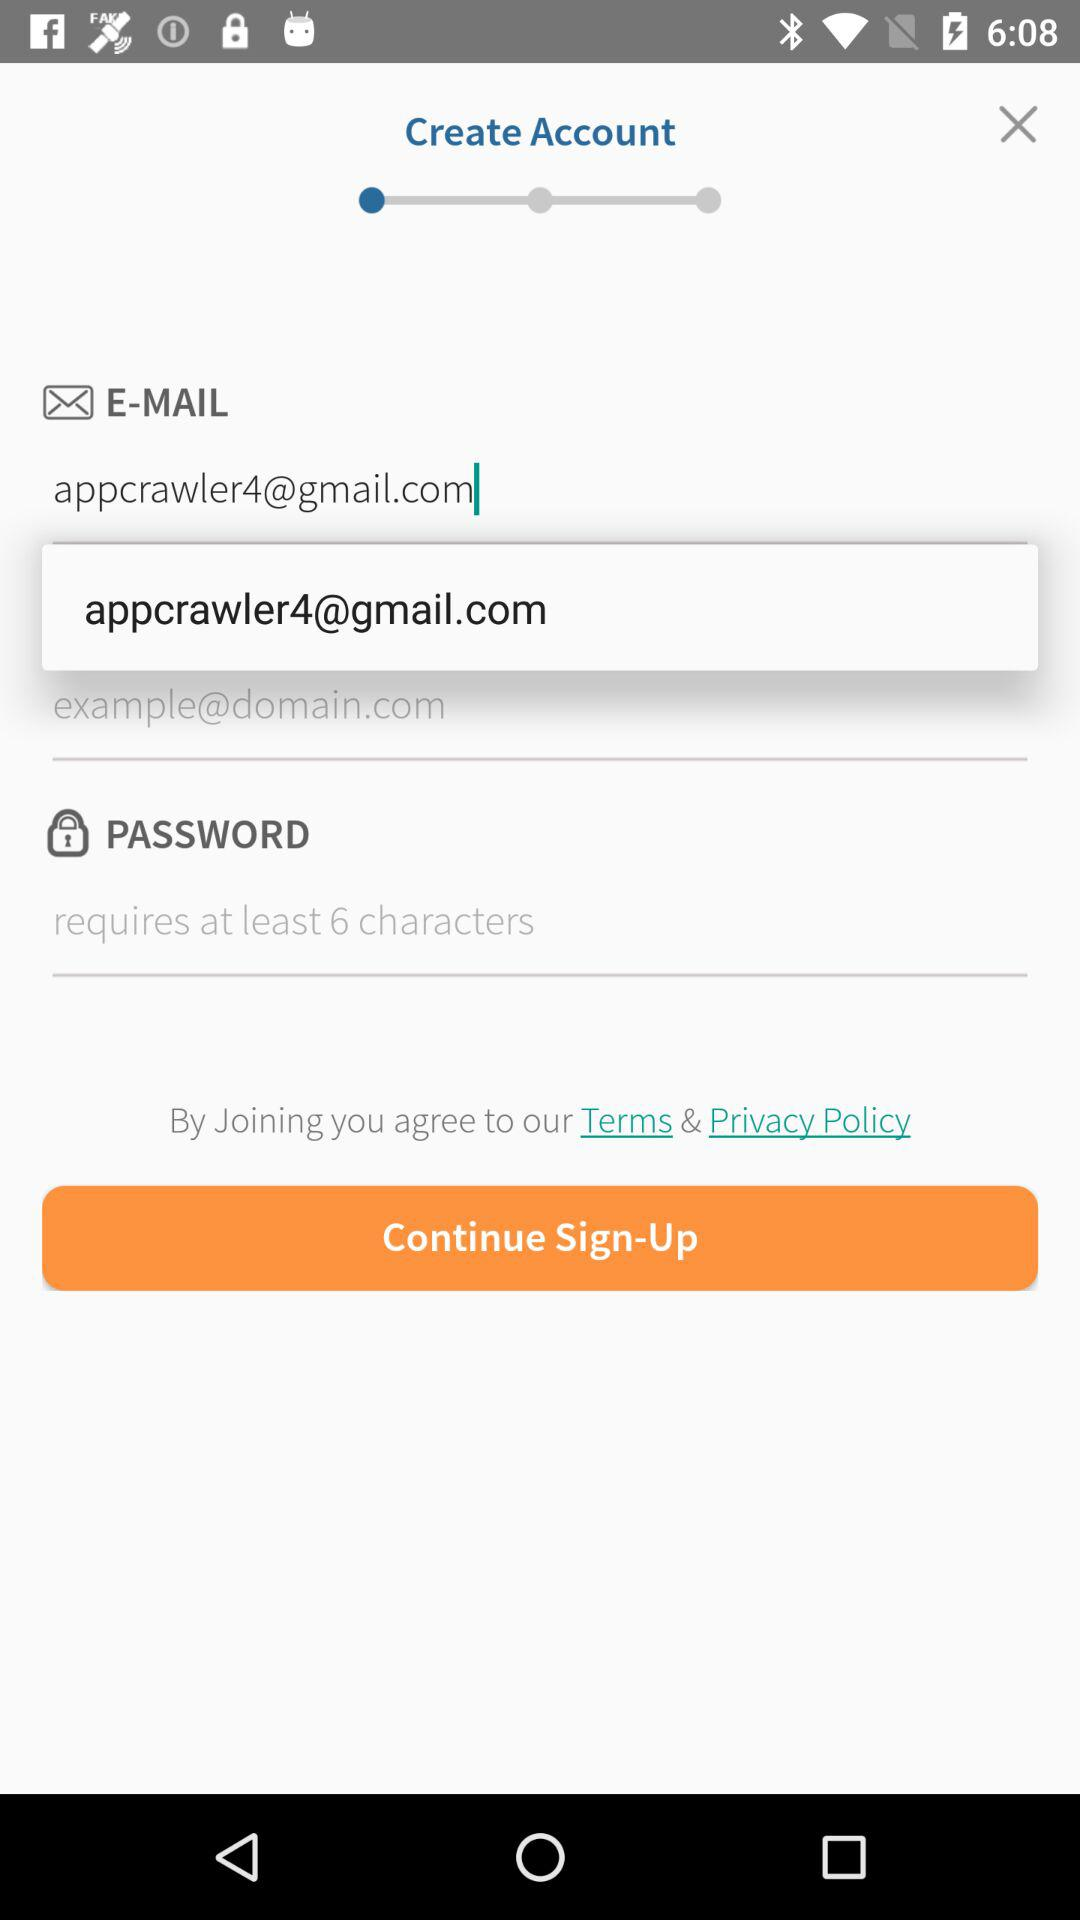What is the email address of the user? The email address of the user is appcrawler4@gmail.com. 